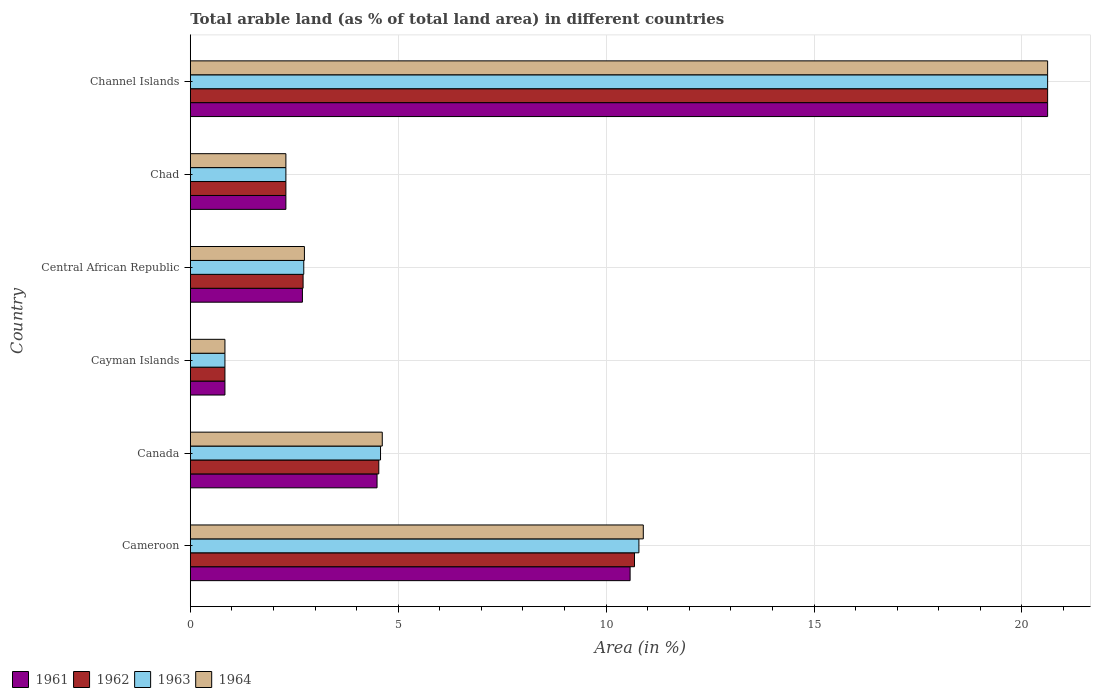Are the number of bars per tick equal to the number of legend labels?
Offer a very short reply. Yes. How many bars are there on the 5th tick from the top?
Ensure brevity in your answer.  4. How many bars are there on the 4th tick from the bottom?
Offer a very short reply. 4. What is the label of the 6th group of bars from the top?
Your answer should be very brief. Cameroon. In how many cases, is the number of bars for a given country not equal to the number of legend labels?
Offer a very short reply. 0. What is the percentage of arable land in 1962 in Central African Republic?
Ensure brevity in your answer.  2.71. Across all countries, what is the maximum percentage of arable land in 1962?
Provide a succinct answer. 20.62. Across all countries, what is the minimum percentage of arable land in 1964?
Give a very brief answer. 0.83. In which country was the percentage of arable land in 1964 maximum?
Offer a very short reply. Channel Islands. In which country was the percentage of arable land in 1962 minimum?
Your answer should be compact. Cayman Islands. What is the total percentage of arable land in 1964 in the graph?
Your response must be concise. 42.01. What is the difference between the percentage of arable land in 1962 in Cameroon and that in Chad?
Offer a terse response. 8.38. What is the difference between the percentage of arable land in 1963 in Cameroon and the percentage of arable land in 1961 in Canada?
Give a very brief answer. 6.3. What is the average percentage of arable land in 1963 per country?
Offer a very short reply. 6.97. What is the difference between the percentage of arable land in 1964 and percentage of arable land in 1961 in Channel Islands?
Ensure brevity in your answer.  0. What is the ratio of the percentage of arable land in 1961 in Chad to that in Channel Islands?
Make the answer very short. 0.11. What is the difference between the highest and the second highest percentage of arable land in 1963?
Give a very brief answer. 9.83. What is the difference between the highest and the lowest percentage of arable land in 1961?
Ensure brevity in your answer.  19.79. Is the sum of the percentage of arable land in 1963 in Cayman Islands and Central African Republic greater than the maximum percentage of arable land in 1961 across all countries?
Offer a terse response. No. Is it the case that in every country, the sum of the percentage of arable land in 1961 and percentage of arable land in 1962 is greater than the percentage of arable land in 1964?
Your answer should be compact. Yes. How many bars are there?
Ensure brevity in your answer.  24. How many countries are there in the graph?
Give a very brief answer. 6. What is the difference between two consecutive major ticks on the X-axis?
Provide a short and direct response. 5. Are the values on the major ticks of X-axis written in scientific E-notation?
Offer a terse response. No. Does the graph contain any zero values?
Offer a very short reply. No. Does the graph contain grids?
Your response must be concise. Yes. Where does the legend appear in the graph?
Offer a very short reply. Bottom left. How many legend labels are there?
Offer a terse response. 4. How are the legend labels stacked?
Give a very brief answer. Horizontal. What is the title of the graph?
Give a very brief answer. Total arable land (as % of total land area) in different countries. What is the label or title of the X-axis?
Your response must be concise. Area (in %). What is the Area (in %) of 1961 in Cameroon?
Give a very brief answer. 10.58. What is the Area (in %) in 1962 in Cameroon?
Offer a terse response. 10.68. What is the Area (in %) of 1963 in Cameroon?
Keep it short and to the point. 10.79. What is the Area (in %) of 1964 in Cameroon?
Your answer should be very brief. 10.89. What is the Area (in %) of 1961 in Canada?
Keep it short and to the point. 4.49. What is the Area (in %) in 1962 in Canada?
Offer a very short reply. 4.53. What is the Area (in %) in 1963 in Canada?
Your answer should be very brief. 4.58. What is the Area (in %) in 1964 in Canada?
Keep it short and to the point. 4.62. What is the Area (in %) in 1961 in Cayman Islands?
Keep it short and to the point. 0.83. What is the Area (in %) in 1962 in Cayman Islands?
Offer a very short reply. 0.83. What is the Area (in %) in 1963 in Cayman Islands?
Offer a very short reply. 0.83. What is the Area (in %) of 1964 in Cayman Islands?
Make the answer very short. 0.83. What is the Area (in %) in 1961 in Central African Republic?
Provide a short and direct response. 2.7. What is the Area (in %) in 1962 in Central African Republic?
Your answer should be very brief. 2.71. What is the Area (in %) in 1963 in Central African Republic?
Your response must be concise. 2.73. What is the Area (in %) of 1964 in Central African Republic?
Provide a short and direct response. 2.74. What is the Area (in %) in 1961 in Chad?
Provide a short and direct response. 2.3. What is the Area (in %) of 1962 in Chad?
Provide a short and direct response. 2.3. What is the Area (in %) of 1963 in Chad?
Make the answer very short. 2.3. What is the Area (in %) in 1964 in Chad?
Offer a very short reply. 2.3. What is the Area (in %) in 1961 in Channel Islands?
Your answer should be very brief. 20.62. What is the Area (in %) in 1962 in Channel Islands?
Provide a short and direct response. 20.62. What is the Area (in %) of 1963 in Channel Islands?
Provide a short and direct response. 20.62. What is the Area (in %) in 1964 in Channel Islands?
Offer a terse response. 20.62. Across all countries, what is the maximum Area (in %) in 1961?
Keep it short and to the point. 20.62. Across all countries, what is the maximum Area (in %) of 1962?
Give a very brief answer. 20.62. Across all countries, what is the maximum Area (in %) of 1963?
Your response must be concise. 20.62. Across all countries, what is the maximum Area (in %) of 1964?
Make the answer very short. 20.62. Across all countries, what is the minimum Area (in %) of 1961?
Your answer should be very brief. 0.83. Across all countries, what is the minimum Area (in %) of 1962?
Your answer should be very brief. 0.83. Across all countries, what is the minimum Area (in %) of 1963?
Ensure brevity in your answer.  0.83. Across all countries, what is the minimum Area (in %) in 1964?
Offer a very short reply. 0.83. What is the total Area (in %) in 1961 in the graph?
Keep it short and to the point. 41.52. What is the total Area (in %) of 1962 in the graph?
Your answer should be very brief. 41.68. What is the total Area (in %) of 1963 in the graph?
Ensure brevity in your answer.  41.84. What is the total Area (in %) of 1964 in the graph?
Your response must be concise. 42.01. What is the difference between the Area (in %) of 1961 in Cameroon and that in Canada?
Keep it short and to the point. 6.09. What is the difference between the Area (in %) of 1962 in Cameroon and that in Canada?
Offer a terse response. 6.15. What is the difference between the Area (in %) of 1963 in Cameroon and that in Canada?
Your answer should be very brief. 6.21. What is the difference between the Area (in %) of 1964 in Cameroon and that in Canada?
Keep it short and to the point. 6.28. What is the difference between the Area (in %) in 1961 in Cameroon and that in Cayman Islands?
Ensure brevity in your answer.  9.74. What is the difference between the Area (in %) of 1962 in Cameroon and that in Cayman Islands?
Offer a terse response. 9.85. What is the difference between the Area (in %) of 1963 in Cameroon and that in Cayman Islands?
Keep it short and to the point. 9.96. What is the difference between the Area (in %) of 1964 in Cameroon and that in Cayman Islands?
Provide a short and direct response. 10.06. What is the difference between the Area (in %) in 1961 in Cameroon and that in Central African Republic?
Offer a very short reply. 7.88. What is the difference between the Area (in %) of 1962 in Cameroon and that in Central African Republic?
Provide a short and direct response. 7.97. What is the difference between the Area (in %) in 1963 in Cameroon and that in Central African Republic?
Your response must be concise. 8.06. What is the difference between the Area (in %) in 1964 in Cameroon and that in Central African Republic?
Offer a very short reply. 8.15. What is the difference between the Area (in %) of 1961 in Cameroon and that in Chad?
Your response must be concise. 8.28. What is the difference between the Area (in %) in 1962 in Cameroon and that in Chad?
Give a very brief answer. 8.38. What is the difference between the Area (in %) in 1963 in Cameroon and that in Chad?
Your response must be concise. 8.49. What is the difference between the Area (in %) of 1964 in Cameroon and that in Chad?
Provide a succinct answer. 8.6. What is the difference between the Area (in %) in 1961 in Cameroon and that in Channel Islands?
Offer a terse response. -10.04. What is the difference between the Area (in %) of 1962 in Cameroon and that in Channel Islands?
Give a very brief answer. -9.94. What is the difference between the Area (in %) in 1963 in Cameroon and that in Channel Islands?
Provide a succinct answer. -9.83. What is the difference between the Area (in %) of 1964 in Cameroon and that in Channel Islands?
Offer a terse response. -9.72. What is the difference between the Area (in %) of 1961 in Canada and that in Cayman Islands?
Ensure brevity in your answer.  3.66. What is the difference between the Area (in %) in 1963 in Canada and that in Cayman Islands?
Your response must be concise. 3.74. What is the difference between the Area (in %) in 1964 in Canada and that in Cayman Islands?
Offer a terse response. 3.78. What is the difference between the Area (in %) of 1961 in Canada and that in Central African Republic?
Your response must be concise. 1.79. What is the difference between the Area (in %) in 1962 in Canada and that in Central African Republic?
Your response must be concise. 1.82. What is the difference between the Area (in %) in 1963 in Canada and that in Central African Republic?
Offer a very short reply. 1.85. What is the difference between the Area (in %) of 1964 in Canada and that in Central African Republic?
Your response must be concise. 1.87. What is the difference between the Area (in %) in 1961 in Canada and that in Chad?
Provide a short and direct response. 2.19. What is the difference between the Area (in %) in 1962 in Canada and that in Chad?
Your answer should be compact. 2.23. What is the difference between the Area (in %) of 1963 in Canada and that in Chad?
Provide a succinct answer. 2.28. What is the difference between the Area (in %) in 1964 in Canada and that in Chad?
Provide a succinct answer. 2.32. What is the difference between the Area (in %) in 1961 in Canada and that in Channel Islands?
Your answer should be very brief. -16.13. What is the difference between the Area (in %) of 1962 in Canada and that in Channel Islands?
Keep it short and to the point. -16.09. What is the difference between the Area (in %) in 1963 in Canada and that in Channel Islands?
Your answer should be compact. -16.04. What is the difference between the Area (in %) in 1964 in Canada and that in Channel Islands?
Keep it short and to the point. -16. What is the difference between the Area (in %) in 1961 in Cayman Islands and that in Central African Republic?
Provide a succinct answer. -1.86. What is the difference between the Area (in %) of 1962 in Cayman Islands and that in Central African Republic?
Your answer should be very brief. -1.88. What is the difference between the Area (in %) of 1963 in Cayman Islands and that in Central African Republic?
Offer a terse response. -1.9. What is the difference between the Area (in %) of 1964 in Cayman Islands and that in Central African Republic?
Make the answer very short. -1.91. What is the difference between the Area (in %) of 1961 in Cayman Islands and that in Chad?
Offer a terse response. -1.47. What is the difference between the Area (in %) of 1962 in Cayman Islands and that in Chad?
Keep it short and to the point. -1.47. What is the difference between the Area (in %) in 1963 in Cayman Islands and that in Chad?
Ensure brevity in your answer.  -1.47. What is the difference between the Area (in %) of 1964 in Cayman Islands and that in Chad?
Offer a terse response. -1.47. What is the difference between the Area (in %) in 1961 in Cayman Islands and that in Channel Islands?
Make the answer very short. -19.79. What is the difference between the Area (in %) of 1962 in Cayman Islands and that in Channel Islands?
Your answer should be very brief. -19.79. What is the difference between the Area (in %) in 1963 in Cayman Islands and that in Channel Islands?
Keep it short and to the point. -19.79. What is the difference between the Area (in %) in 1964 in Cayman Islands and that in Channel Islands?
Offer a very short reply. -19.79. What is the difference between the Area (in %) in 1961 in Central African Republic and that in Chad?
Your answer should be very brief. 0.4. What is the difference between the Area (in %) of 1962 in Central African Republic and that in Chad?
Offer a terse response. 0.41. What is the difference between the Area (in %) of 1963 in Central African Republic and that in Chad?
Provide a succinct answer. 0.43. What is the difference between the Area (in %) of 1964 in Central African Republic and that in Chad?
Offer a very short reply. 0.45. What is the difference between the Area (in %) of 1961 in Central African Republic and that in Channel Islands?
Keep it short and to the point. -17.92. What is the difference between the Area (in %) in 1962 in Central African Republic and that in Channel Islands?
Offer a terse response. -17.91. What is the difference between the Area (in %) in 1963 in Central African Republic and that in Channel Islands?
Provide a short and direct response. -17.89. What is the difference between the Area (in %) of 1964 in Central African Republic and that in Channel Islands?
Make the answer very short. -17.87. What is the difference between the Area (in %) of 1961 in Chad and that in Channel Islands?
Keep it short and to the point. -18.32. What is the difference between the Area (in %) of 1962 in Chad and that in Channel Islands?
Your response must be concise. -18.32. What is the difference between the Area (in %) of 1963 in Chad and that in Channel Islands?
Give a very brief answer. -18.32. What is the difference between the Area (in %) of 1964 in Chad and that in Channel Islands?
Ensure brevity in your answer.  -18.32. What is the difference between the Area (in %) of 1961 in Cameroon and the Area (in %) of 1962 in Canada?
Keep it short and to the point. 6.04. What is the difference between the Area (in %) of 1961 in Cameroon and the Area (in %) of 1963 in Canada?
Your answer should be compact. 6. What is the difference between the Area (in %) in 1961 in Cameroon and the Area (in %) in 1964 in Canada?
Your response must be concise. 5.96. What is the difference between the Area (in %) of 1962 in Cameroon and the Area (in %) of 1963 in Canada?
Keep it short and to the point. 6.11. What is the difference between the Area (in %) of 1962 in Cameroon and the Area (in %) of 1964 in Canada?
Offer a terse response. 6.07. What is the difference between the Area (in %) of 1963 in Cameroon and the Area (in %) of 1964 in Canada?
Offer a very short reply. 6.17. What is the difference between the Area (in %) of 1961 in Cameroon and the Area (in %) of 1962 in Cayman Islands?
Keep it short and to the point. 9.74. What is the difference between the Area (in %) in 1961 in Cameroon and the Area (in %) in 1963 in Cayman Islands?
Your response must be concise. 9.74. What is the difference between the Area (in %) in 1961 in Cameroon and the Area (in %) in 1964 in Cayman Islands?
Provide a short and direct response. 9.74. What is the difference between the Area (in %) of 1962 in Cameroon and the Area (in %) of 1963 in Cayman Islands?
Your answer should be very brief. 9.85. What is the difference between the Area (in %) of 1962 in Cameroon and the Area (in %) of 1964 in Cayman Islands?
Provide a succinct answer. 9.85. What is the difference between the Area (in %) of 1963 in Cameroon and the Area (in %) of 1964 in Cayman Islands?
Your answer should be very brief. 9.96. What is the difference between the Area (in %) of 1961 in Cameroon and the Area (in %) of 1962 in Central African Republic?
Provide a short and direct response. 7.86. What is the difference between the Area (in %) in 1961 in Cameroon and the Area (in %) in 1963 in Central African Republic?
Make the answer very short. 7.85. What is the difference between the Area (in %) of 1961 in Cameroon and the Area (in %) of 1964 in Central African Republic?
Give a very brief answer. 7.83. What is the difference between the Area (in %) in 1962 in Cameroon and the Area (in %) in 1963 in Central African Republic?
Offer a terse response. 7.95. What is the difference between the Area (in %) of 1962 in Cameroon and the Area (in %) of 1964 in Central African Republic?
Ensure brevity in your answer.  7.94. What is the difference between the Area (in %) in 1963 in Cameroon and the Area (in %) in 1964 in Central African Republic?
Provide a succinct answer. 8.04. What is the difference between the Area (in %) of 1961 in Cameroon and the Area (in %) of 1962 in Chad?
Give a very brief answer. 8.28. What is the difference between the Area (in %) of 1961 in Cameroon and the Area (in %) of 1963 in Chad?
Provide a succinct answer. 8.28. What is the difference between the Area (in %) in 1961 in Cameroon and the Area (in %) in 1964 in Chad?
Make the answer very short. 8.28. What is the difference between the Area (in %) of 1962 in Cameroon and the Area (in %) of 1963 in Chad?
Make the answer very short. 8.38. What is the difference between the Area (in %) of 1962 in Cameroon and the Area (in %) of 1964 in Chad?
Provide a short and direct response. 8.38. What is the difference between the Area (in %) in 1963 in Cameroon and the Area (in %) in 1964 in Chad?
Offer a very short reply. 8.49. What is the difference between the Area (in %) in 1961 in Cameroon and the Area (in %) in 1962 in Channel Islands?
Provide a succinct answer. -10.04. What is the difference between the Area (in %) of 1961 in Cameroon and the Area (in %) of 1963 in Channel Islands?
Provide a short and direct response. -10.04. What is the difference between the Area (in %) of 1961 in Cameroon and the Area (in %) of 1964 in Channel Islands?
Make the answer very short. -10.04. What is the difference between the Area (in %) in 1962 in Cameroon and the Area (in %) in 1963 in Channel Islands?
Offer a terse response. -9.94. What is the difference between the Area (in %) of 1962 in Cameroon and the Area (in %) of 1964 in Channel Islands?
Your answer should be very brief. -9.94. What is the difference between the Area (in %) in 1963 in Cameroon and the Area (in %) in 1964 in Channel Islands?
Ensure brevity in your answer.  -9.83. What is the difference between the Area (in %) in 1961 in Canada and the Area (in %) in 1962 in Cayman Islands?
Your answer should be very brief. 3.66. What is the difference between the Area (in %) in 1961 in Canada and the Area (in %) in 1963 in Cayman Islands?
Your response must be concise. 3.66. What is the difference between the Area (in %) of 1961 in Canada and the Area (in %) of 1964 in Cayman Islands?
Your answer should be very brief. 3.66. What is the difference between the Area (in %) of 1962 in Canada and the Area (in %) of 1963 in Cayman Islands?
Make the answer very short. 3.7. What is the difference between the Area (in %) of 1963 in Canada and the Area (in %) of 1964 in Cayman Islands?
Provide a short and direct response. 3.74. What is the difference between the Area (in %) in 1961 in Canada and the Area (in %) in 1962 in Central African Republic?
Provide a short and direct response. 1.78. What is the difference between the Area (in %) in 1961 in Canada and the Area (in %) in 1963 in Central African Republic?
Provide a short and direct response. 1.76. What is the difference between the Area (in %) in 1961 in Canada and the Area (in %) in 1964 in Central African Republic?
Ensure brevity in your answer.  1.75. What is the difference between the Area (in %) of 1962 in Canada and the Area (in %) of 1963 in Central African Republic?
Give a very brief answer. 1.8. What is the difference between the Area (in %) in 1962 in Canada and the Area (in %) in 1964 in Central African Republic?
Keep it short and to the point. 1.79. What is the difference between the Area (in %) of 1963 in Canada and the Area (in %) of 1964 in Central African Republic?
Make the answer very short. 1.83. What is the difference between the Area (in %) in 1961 in Canada and the Area (in %) in 1962 in Chad?
Keep it short and to the point. 2.19. What is the difference between the Area (in %) of 1961 in Canada and the Area (in %) of 1963 in Chad?
Make the answer very short. 2.19. What is the difference between the Area (in %) in 1961 in Canada and the Area (in %) in 1964 in Chad?
Ensure brevity in your answer.  2.19. What is the difference between the Area (in %) in 1962 in Canada and the Area (in %) in 1963 in Chad?
Provide a short and direct response. 2.23. What is the difference between the Area (in %) in 1962 in Canada and the Area (in %) in 1964 in Chad?
Provide a succinct answer. 2.23. What is the difference between the Area (in %) in 1963 in Canada and the Area (in %) in 1964 in Chad?
Offer a terse response. 2.28. What is the difference between the Area (in %) of 1961 in Canada and the Area (in %) of 1962 in Channel Islands?
Offer a terse response. -16.13. What is the difference between the Area (in %) in 1961 in Canada and the Area (in %) in 1963 in Channel Islands?
Provide a succinct answer. -16.13. What is the difference between the Area (in %) in 1961 in Canada and the Area (in %) in 1964 in Channel Islands?
Provide a succinct answer. -16.13. What is the difference between the Area (in %) of 1962 in Canada and the Area (in %) of 1963 in Channel Islands?
Your answer should be compact. -16.09. What is the difference between the Area (in %) of 1962 in Canada and the Area (in %) of 1964 in Channel Islands?
Your answer should be very brief. -16.09. What is the difference between the Area (in %) in 1963 in Canada and the Area (in %) in 1964 in Channel Islands?
Your response must be concise. -16.04. What is the difference between the Area (in %) of 1961 in Cayman Islands and the Area (in %) of 1962 in Central African Republic?
Make the answer very short. -1.88. What is the difference between the Area (in %) of 1961 in Cayman Islands and the Area (in %) of 1963 in Central African Republic?
Make the answer very short. -1.9. What is the difference between the Area (in %) in 1961 in Cayman Islands and the Area (in %) in 1964 in Central African Republic?
Make the answer very short. -1.91. What is the difference between the Area (in %) in 1962 in Cayman Islands and the Area (in %) in 1963 in Central African Republic?
Ensure brevity in your answer.  -1.9. What is the difference between the Area (in %) in 1962 in Cayman Islands and the Area (in %) in 1964 in Central African Republic?
Give a very brief answer. -1.91. What is the difference between the Area (in %) in 1963 in Cayman Islands and the Area (in %) in 1964 in Central African Republic?
Ensure brevity in your answer.  -1.91. What is the difference between the Area (in %) of 1961 in Cayman Islands and the Area (in %) of 1962 in Chad?
Keep it short and to the point. -1.47. What is the difference between the Area (in %) of 1961 in Cayman Islands and the Area (in %) of 1963 in Chad?
Your answer should be compact. -1.47. What is the difference between the Area (in %) of 1961 in Cayman Islands and the Area (in %) of 1964 in Chad?
Keep it short and to the point. -1.47. What is the difference between the Area (in %) in 1962 in Cayman Islands and the Area (in %) in 1963 in Chad?
Keep it short and to the point. -1.47. What is the difference between the Area (in %) of 1962 in Cayman Islands and the Area (in %) of 1964 in Chad?
Your response must be concise. -1.47. What is the difference between the Area (in %) of 1963 in Cayman Islands and the Area (in %) of 1964 in Chad?
Provide a succinct answer. -1.47. What is the difference between the Area (in %) of 1961 in Cayman Islands and the Area (in %) of 1962 in Channel Islands?
Provide a short and direct response. -19.79. What is the difference between the Area (in %) of 1961 in Cayman Islands and the Area (in %) of 1963 in Channel Islands?
Make the answer very short. -19.79. What is the difference between the Area (in %) of 1961 in Cayman Islands and the Area (in %) of 1964 in Channel Islands?
Make the answer very short. -19.79. What is the difference between the Area (in %) of 1962 in Cayman Islands and the Area (in %) of 1963 in Channel Islands?
Provide a short and direct response. -19.79. What is the difference between the Area (in %) in 1962 in Cayman Islands and the Area (in %) in 1964 in Channel Islands?
Keep it short and to the point. -19.79. What is the difference between the Area (in %) of 1963 in Cayman Islands and the Area (in %) of 1964 in Channel Islands?
Offer a very short reply. -19.79. What is the difference between the Area (in %) of 1961 in Central African Republic and the Area (in %) of 1962 in Chad?
Offer a terse response. 0.4. What is the difference between the Area (in %) of 1961 in Central African Republic and the Area (in %) of 1963 in Chad?
Your answer should be compact. 0.4. What is the difference between the Area (in %) of 1961 in Central African Republic and the Area (in %) of 1964 in Chad?
Give a very brief answer. 0.4. What is the difference between the Area (in %) of 1962 in Central African Republic and the Area (in %) of 1963 in Chad?
Ensure brevity in your answer.  0.41. What is the difference between the Area (in %) of 1962 in Central African Republic and the Area (in %) of 1964 in Chad?
Offer a terse response. 0.41. What is the difference between the Area (in %) of 1963 in Central African Republic and the Area (in %) of 1964 in Chad?
Provide a succinct answer. 0.43. What is the difference between the Area (in %) in 1961 in Central African Republic and the Area (in %) in 1962 in Channel Islands?
Offer a terse response. -17.92. What is the difference between the Area (in %) of 1961 in Central African Republic and the Area (in %) of 1963 in Channel Islands?
Your answer should be very brief. -17.92. What is the difference between the Area (in %) in 1961 in Central African Republic and the Area (in %) in 1964 in Channel Islands?
Offer a terse response. -17.92. What is the difference between the Area (in %) of 1962 in Central African Republic and the Area (in %) of 1963 in Channel Islands?
Ensure brevity in your answer.  -17.91. What is the difference between the Area (in %) in 1962 in Central African Republic and the Area (in %) in 1964 in Channel Islands?
Provide a short and direct response. -17.91. What is the difference between the Area (in %) of 1963 in Central African Republic and the Area (in %) of 1964 in Channel Islands?
Keep it short and to the point. -17.89. What is the difference between the Area (in %) in 1961 in Chad and the Area (in %) in 1962 in Channel Islands?
Your answer should be very brief. -18.32. What is the difference between the Area (in %) of 1961 in Chad and the Area (in %) of 1963 in Channel Islands?
Your response must be concise. -18.32. What is the difference between the Area (in %) of 1961 in Chad and the Area (in %) of 1964 in Channel Islands?
Provide a short and direct response. -18.32. What is the difference between the Area (in %) in 1962 in Chad and the Area (in %) in 1963 in Channel Islands?
Make the answer very short. -18.32. What is the difference between the Area (in %) in 1962 in Chad and the Area (in %) in 1964 in Channel Islands?
Give a very brief answer. -18.32. What is the difference between the Area (in %) in 1963 in Chad and the Area (in %) in 1964 in Channel Islands?
Make the answer very short. -18.32. What is the average Area (in %) of 1961 per country?
Keep it short and to the point. 6.92. What is the average Area (in %) of 1962 per country?
Provide a short and direct response. 6.95. What is the average Area (in %) in 1963 per country?
Your response must be concise. 6.97. What is the average Area (in %) of 1964 per country?
Give a very brief answer. 7. What is the difference between the Area (in %) of 1961 and Area (in %) of 1962 in Cameroon?
Your answer should be very brief. -0.11. What is the difference between the Area (in %) in 1961 and Area (in %) in 1963 in Cameroon?
Offer a very short reply. -0.21. What is the difference between the Area (in %) of 1961 and Area (in %) of 1964 in Cameroon?
Your answer should be compact. -0.32. What is the difference between the Area (in %) in 1962 and Area (in %) in 1963 in Cameroon?
Your response must be concise. -0.11. What is the difference between the Area (in %) of 1962 and Area (in %) of 1964 in Cameroon?
Keep it short and to the point. -0.21. What is the difference between the Area (in %) in 1963 and Area (in %) in 1964 in Cameroon?
Your response must be concise. -0.11. What is the difference between the Area (in %) in 1961 and Area (in %) in 1962 in Canada?
Offer a terse response. -0.04. What is the difference between the Area (in %) of 1961 and Area (in %) of 1963 in Canada?
Your answer should be very brief. -0.08. What is the difference between the Area (in %) of 1961 and Area (in %) of 1964 in Canada?
Offer a terse response. -0.13. What is the difference between the Area (in %) of 1962 and Area (in %) of 1963 in Canada?
Your answer should be very brief. -0.04. What is the difference between the Area (in %) in 1962 and Area (in %) in 1964 in Canada?
Give a very brief answer. -0.08. What is the difference between the Area (in %) in 1963 and Area (in %) in 1964 in Canada?
Provide a succinct answer. -0.04. What is the difference between the Area (in %) in 1962 and Area (in %) in 1964 in Cayman Islands?
Give a very brief answer. 0. What is the difference between the Area (in %) of 1961 and Area (in %) of 1962 in Central African Republic?
Ensure brevity in your answer.  -0.02. What is the difference between the Area (in %) of 1961 and Area (in %) of 1963 in Central African Republic?
Keep it short and to the point. -0.03. What is the difference between the Area (in %) in 1961 and Area (in %) in 1964 in Central African Republic?
Your answer should be compact. -0.05. What is the difference between the Area (in %) of 1962 and Area (in %) of 1963 in Central African Republic?
Give a very brief answer. -0.02. What is the difference between the Area (in %) of 1962 and Area (in %) of 1964 in Central African Republic?
Provide a short and direct response. -0.03. What is the difference between the Area (in %) in 1963 and Area (in %) in 1964 in Central African Republic?
Your response must be concise. -0.02. What is the difference between the Area (in %) of 1961 and Area (in %) of 1962 in Chad?
Keep it short and to the point. 0. What is the difference between the Area (in %) of 1961 and Area (in %) of 1963 in Chad?
Make the answer very short. 0. What is the difference between the Area (in %) in 1962 and Area (in %) in 1963 in Chad?
Provide a succinct answer. 0. What is the difference between the Area (in %) in 1962 and Area (in %) in 1964 in Chad?
Keep it short and to the point. 0. What is the difference between the Area (in %) in 1961 and Area (in %) in 1962 in Channel Islands?
Your response must be concise. 0. What is the difference between the Area (in %) in 1961 and Area (in %) in 1963 in Channel Islands?
Your answer should be very brief. 0. What is the difference between the Area (in %) of 1962 and Area (in %) of 1963 in Channel Islands?
Your response must be concise. 0. What is the difference between the Area (in %) in 1963 and Area (in %) in 1964 in Channel Islands?
Your answer should be compact. 0. What is the ratio of the Area (in %) of 1961 in Cameroon to that in Canada?
Keep it short and to the point. 2.35. What is the ratio of the Area (in %) of 1962 in Cameroon to that in Canada?
Give a very brief answer. 2.36. What is the ratio of the Area (in %) in 1963 in Cameroon to that in Canada?
Your response must be concise. 2.36. What is the ratio of the Area (in %) in 1964 in Cameroon to that in Canada?
Ensure brevity in your answer.  2.36. What is the ratio of the Area (in %) in 1961 in Cameroon to that in Cayman Islands?
Give a very brief answer. 12.69. What is the ratio of the Area (in %) of 1962 in Cameroon to that in Cayman Islands?
Offer a very short reply. 12.82. What is the ratio of the Area (in %) of 1963 in Cameroon to that in Cayman Islands?
Your answer should be very brief. 12.95. What is the ratio of the Area (in %) in 1964 in Cameroon to that in Cayman Islands?
Ensure brevity in your answer.  13.07. What is the ratio of the Area (in %) in 1961 in Cameroon to that in Central African Republic?
Provide a succinct answer. 3.92. What is the ratio of the Area (in %) of 1962 in Cameroon to that in Central African Republic?
Make the answer very short. 3.94. What is the ratio of the Area (in %) in 1963 in Cameroon to that in Central African Republic?
Provide a short and direct response. 3.95. What is the ratio of the Area (in %) in 1964 in Cameroon to that in Central African Republic?
Your answer should be very brief. 3.97. What is the ratio of the Area (in %) of 1961 in Cameroon to that in Chad?
Offer a terse response. 4.6. What is the ratio of the Area (in %) in 1962 in Cameroon to that in Chad?
Offer a very short reply. 4.65. What is the ratio of the Area (in %) of 1963 in Cameroon to that in Chad?
Ensure brevity in your answer.  4.69. What is the ratio of the Area (in %) of 1964 in Cameroon to that in Chad?
Give a very brief answer. 4.74. What is the ratio of the Area (in %) in 1961 in Cameroon to that in Channel Islands?
Offer a very short reply. 0.51. What is the ratio of the Area (in %) of 1962 in Cameroon to that in Channel Islands?
Your answer should be very brief. 0.52. What is the ratio of the Area (in %) in 1963 in Cameroon to that in Channel Islands?
Your answer should be compact. 0.52. What is the ratio of the Area (in %) in 1964 in Cameroon to that in Channel Islands?
Your answer should be very brief. 0.53. What is the ratio of the Area (in %) of 1961 in Canada to that in Cayman Islands?
Offer a very short reply. 5.39. What is the ratio of the Area (in %) in 1962 in Canada to that in Cayman Islands?
Give a very brief answer. 5.44. What is the ratio of the Area (in %) in 1963 in Canada to that in Cayman Islands?
Offer a very short reply. 5.49. What is the ratio of the Area (in %) in 1964 in Canada to that in Cayman Islands?
Give a very brief answer. 5.54. What is the ratio of the Area (in %) of 1961 in Canada to that in Central African Republic?
Your answer should be compact. 1.67. What is the ratio of the Area (in %) in 1962 in Canada to that in Central African Republic?
Provide a succinct answer. 1.67. What is the ratio of the Area (in %) of 1963 in Canada to that in Central African Republic?
Give a very brief answer. 1.68. What is the ratio of the Area (in %) in 1964 in Canada to that in Central African Republic?
Ensure brevity in your answer.  1.68. What is the ratio of the Area (in %) of 1961 in Canada to that in Chad?
Offer a terse response. 1.95. What is the ratio of the Area (in %) of 1962 in Canada to that in Chad?
Your response must be concise. 1.97. What is the ratio of the Area (in %) of 1963 in Canada to that in Chad?
Keep it short and to the point. 1.99. What is the ratio of the Area (in %) of 1964 in Canada to that in Chad?
Your answer should be compact. 2.01. What is the ratio of the Area (in %) of 1961 in Canada to that in Channel Islands?
Your response must be concise. 0.22. What is the ratio of the Area (in %) of 1962 in Canada to that in Channel Islands?
Ensure brevity in your answer.  0.22. What is the ratio of the Area (in %) of 1963 in Canada to that in Channel Islands?
Keep it short and to the point. 0.22. What is the ratio of the Area (in %) in 1964 in Canada to that in Channel Islands?
Your answer should be compact. 0.22. What is the ratio of the Area (in %) of 1961 in Cayman Islands to that in Central African Republic?
Make the answer very short. 0.31. What is the ratio of the Area (in %) of 1962 in Cayman Islands to that in Central African Republic?
Give a very brief answer. 0.31. What is the ratio of the Area (in %) in 1963 in Cayman Islands to that in Central African Republic?
Ensure brevity in your answer.  0.31. What is the ratio of the Area (in %) in 1964 in Cayman Islands to that in Central African Republic?
Give a very brief answer. 0.3. What is the ratio of the Area (in %) of 1961 in Cayman Islands to that in Chad?
Provide a succinct answer. 0.36. What is the ratio of the Area (in %) of 1962 in Cayman Islands to that in Chad?
Ensure brevity in your answer.  0.36. What is the ratio of the Area (in %) in 1963 in Cayman Islands to that in Chad?
Ensure brevity in your answer.  0.36. What is the ratio of the Area (in %) in 1964 in Cayman Islands to that in Chad?
Give a very brief answer. 0.36. What is the ratio of the Area (in %) of 1961 in Cayman Islands to that in Channel Islands?
Offer a terse response. 0.04. What is the ratio of the Area (in %) in 1962 in Cayman Islands to that in Channel Islands?
Your response must be concise. 0.04. What is the ratio of the Area (in %) of 1963 in Cayman Islands to that in Channel Islands?
Your answer should be very brief. 0.04. What is the ratio of the Area (in %) in 1964 in Cayman Islands to that in Channel Islands?
Provide a short and direct response. 0.04. What is the ratio of the Area (in %) in 1961 in Central African Republic to that in Chad?
Give a very brief answer. 1.17. What is the ratio of the Area (in %) in 1962 in Central African Republic to that in Chad?
Offer a terse response. 1.18. What is the ratio of the Area (in %) in 1963 in Central African Republic to that in Chad?
Offer a terse response. 1.19. What is the ratio of the Area (in %) of 1964 in Central African Republic to that in Chad?
Your answer should be compact. 1.19. What is the ratio of the Area (in %) of 1961 in Central African Republic to that in Channel Islands?
Make the answer very short. 0.13. What is the ratio of the Area (in %) in 1962 in Central African Republic to that in Channel Islands?
Give a very brief answer. 0.13. What is the ratio of the Area (in %) of 1963 in Central African Republic to that in Channel Islands?
Provide a succinct answer. 0.13. What is the ratio of the Area (in %) of 1964 in Central African Republic to that in Channel Islands?
Give a very brief answer. 0.13. What is the ratio of the Area (in %) of 1961 in Chad to that in Channel Islands?
Provide a short and direct response. 0.11. What is the ratio of the Area (in %) of 1962 in Chad to that in Channel Islands?
Offer a very short reply. 0.11. What is the ratio of the Area (in %) of 1963 in Chad to that in Channel Islands?
Ensure brevity in your answer.  0.11. What is the ratio of the Area (in %) in 1964 in Chad to that in Channel Islands?
Provide a succinct answer. 0.11. What is the difference between the highest and the second highest Area (in %) in 1961?
Your response must be concise. 10.04. What is the difference between the highest and the second highest Area (in %) of 1962?
Your answer should be very brief. 9.94. What is the difference between the highest and the second highest Area (in %) in 1963?
Your answer should be very brief. 9.83. What is the difference between the highest and the second highest Area (in %) of 1964?
Your answer should be very brief. 9.72. What is the difference between the highest and the lowest Area (in %) in 1961?
Provide a short and direct response. 19.79. What is the difference between the highest and the lowest Area (in %) of 1962?
Ensure brevity in your answer.  19.79. What is the difference between the highest and the lowest Area (in %) in 1963?
Your answer should be very brief. 19.79. What is the difference between the highest and the lowest Area (in %) of 1964?
Ensure brevity in your answer.  19.79. 